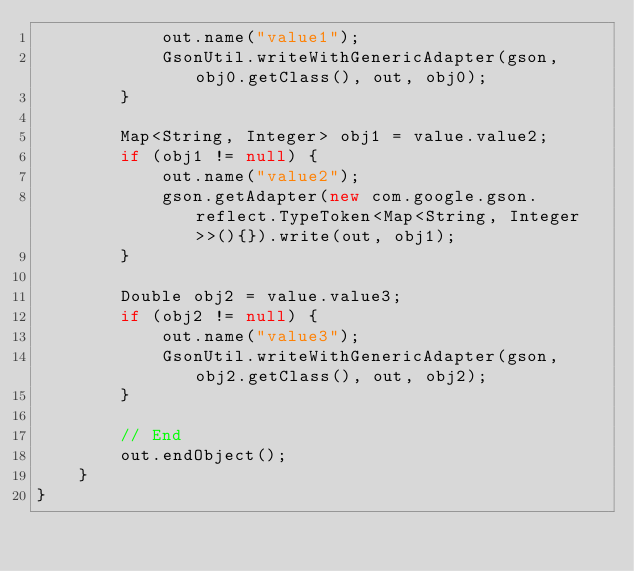<code> <loc_0><loc_0><loc_500><loc_500><_Java_>            out.name("value1");
            GsonUtil.writeWithGenericAdapter(gson, obj0.getClass(), out, obj0);
        }

        Map<String, Integer> obj1 = value.value2;
        if (obj1 != null) {
            out.name("value2");
            gson.getAdapter(new com.google.gson.reflect.TypeToken<Map<String, Integer>>(){}).write(out, obj1);
        }

        Double obj2 = value.value3;
        if (obj2 != null) {
            out.name("value3");
            GsonUtil.writeWithGenericAdapter(gson, obj2.getClass(), out, obj2);
        }

        // End
        out.endObject();
    }
}</code> 